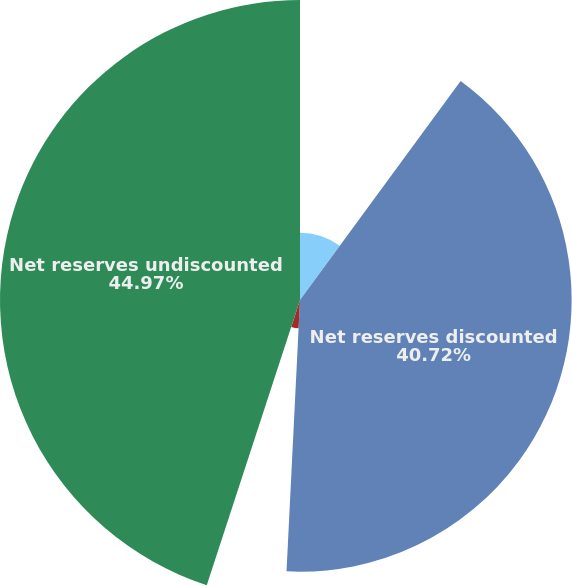Convert chart to OTSL. <chart><loc_0><loc_0><loc_500><loc_500><pie_chart><fcel>(In millions) Year Ended<fcel>Net reserves discounted<fcel>Reserve discount<fcel>Net reserves undiscounted<nl><fcel>10.07%<fcel>40.72%<fcel>4.24%<fcel>44.97%<nl></chart> 